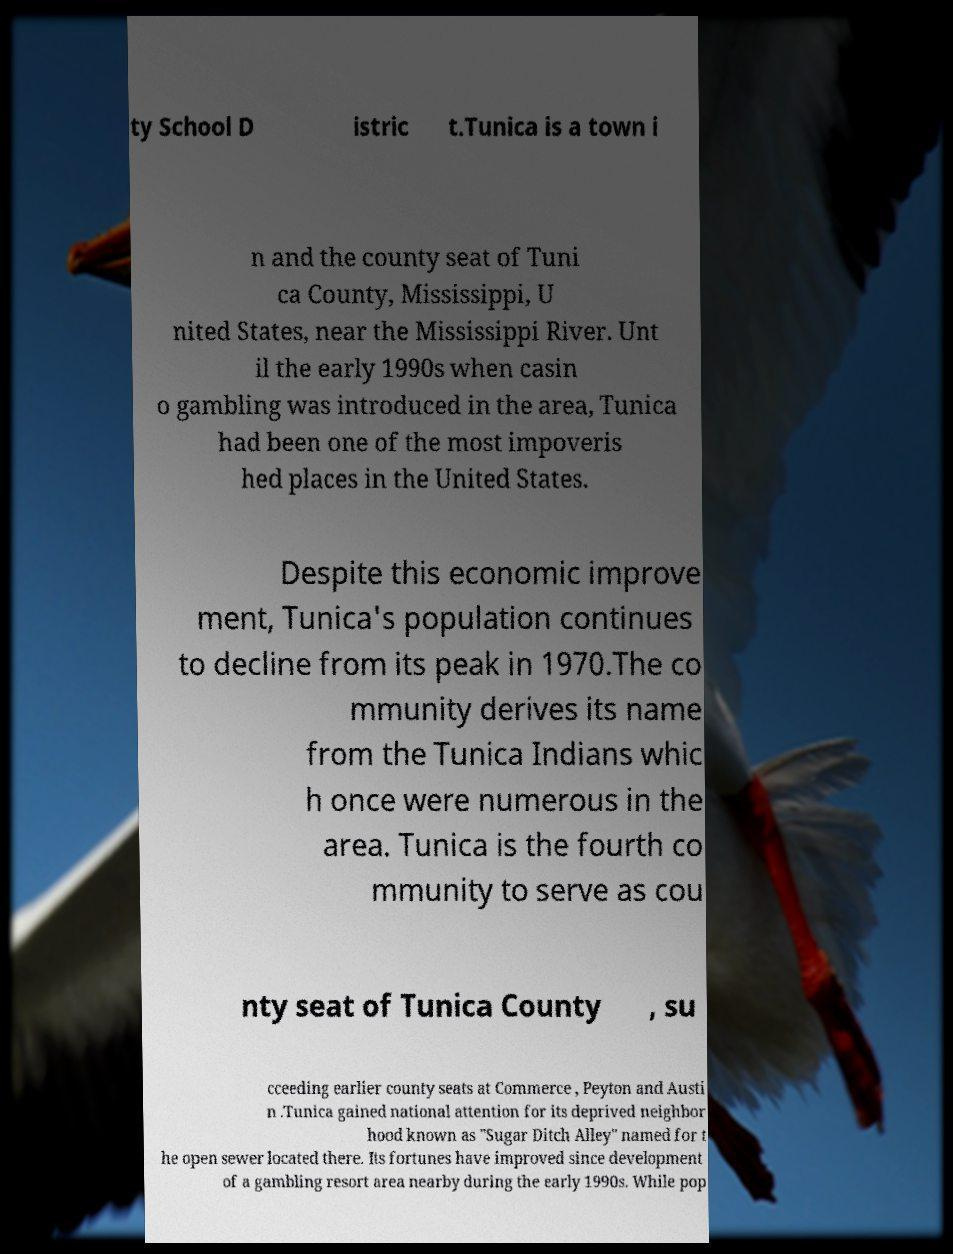For documentation purposes, I need the text within this image transcribed. Could you provide that? ty School D istric t.Tunica is a town i n and the county seat of Tuni ca County, Mississippi, U nited States, near the Mississippi River. Unt il the early 1990s when casin o gambling was introduced in the area, Tunica had been one of the most impoveris hed places in the United States. Despite this economic improve ment, Tunica's population continues to decline from its peak in 1970.The co mmunity derives its name from the Tunica Indians whic h once were numerous in the area. Tunica is the fourth co mmunity to serve as cou nty seat of Tunica County , su cceeding earlier county seats at Commerce , Peyton and Austi n .Tunica gained national attention for its deprived neighbor hood known as "Sugar Ditch Alley" named for t he open sewer located there. Its fortunes have improved since development of a gambling resort area nearby during the early 1990s. While pop 